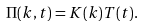Convert formula to latex. <formula><loc_0><loc_0><loc_500><loc_500>\Pi ( k , t ) = K ( k ) T ( t ) .</formula> 